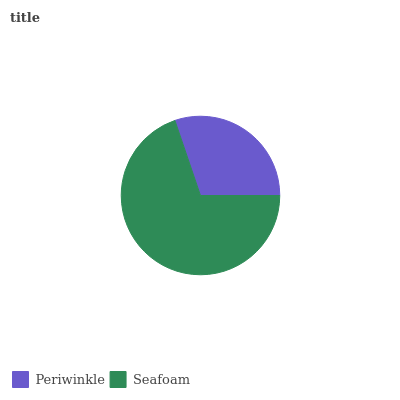Is Periwinkle the minimum?
Answer yes or no. Yes. Is Seafoam the maximum?
Answer yes or no. Yes. Is Seafoam the minimum?
Answer yes or no. No. Is Seafoam greater than Periwinkle?
Answer yes or no. Yes. Is Periwinkle less than Seafoam?
Answer yes or no. Yes. Is Periwinkle greater than Seafoam?
Answer yes or no. No. Is Seafoam less than Periwinkle?
Answer yes or no. No. Is Seafoam the high median?
Answer yes or no. Yes. Is Periwinkle the low median?
Answer yes or no. Yes. Is Periwinkle the high median?
Answer yes or no. No. Is Seafoam the low median?
Answer yes or no. No. 